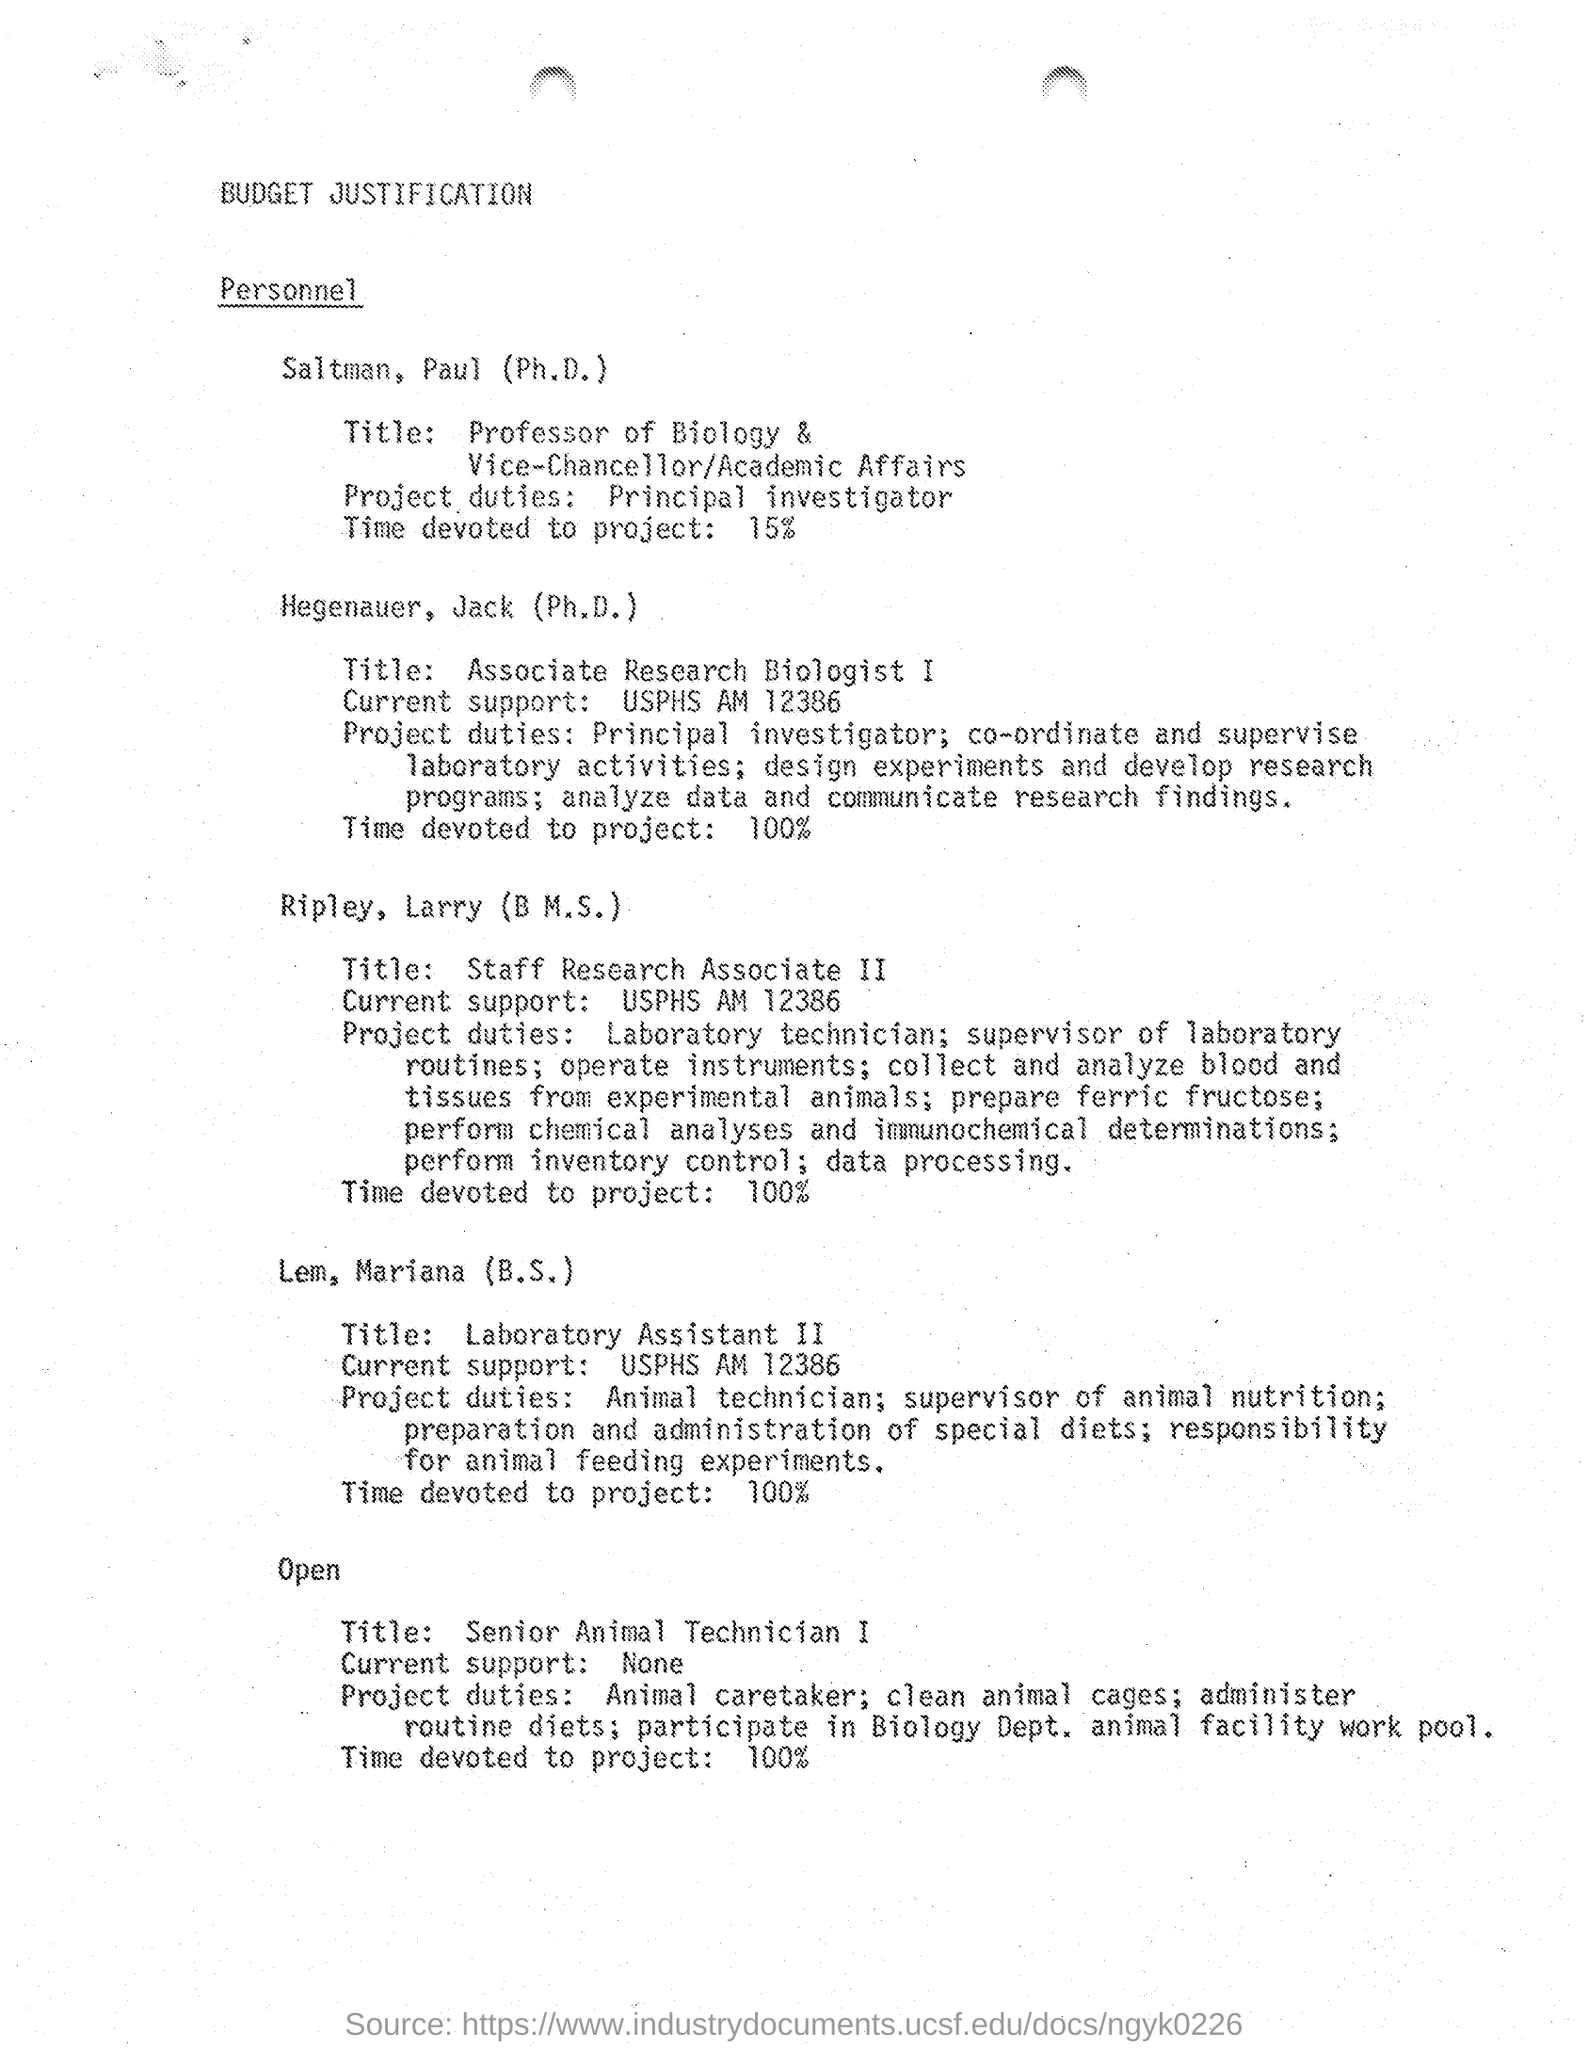Point out several critical features in this image. Saltman, Paul (Ph.D.) devotes 15% of his time to the project. Hegenauer, Jack (Ph. D.), who holds the job title of Associate Research Biologist I, is a professional with expertise in the field of biology. Hegenauer, Jack (Ph.D.) devotes 100% of his time to the project. Lem, Mariana (B.S) is a Laboratory Assistant II. Saltman, Paul (Ph.D.), who holds the position of Professor of Biology and serves as the Vice-Chancellor/Academic Affairs, is a highly esteemed individual in the academic community. 